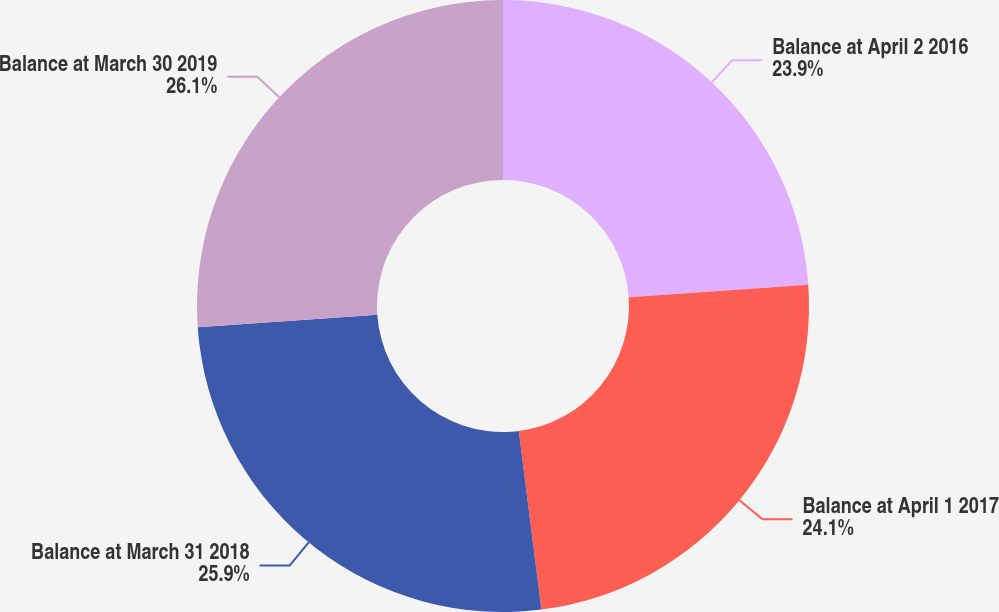<chart> <loc_0><loc_0><loc_500><loc_500><pie_chart><fcel>Balance at April 2 2016<fcel>Balance at April 1 2017<fcel>Balance at March 31 2018<fcel>Balance at March 30 2019<nl><fcel>23.9%<fcel>24.1%<fcel>25.9%<fcel>26.1%<nl></chart> 